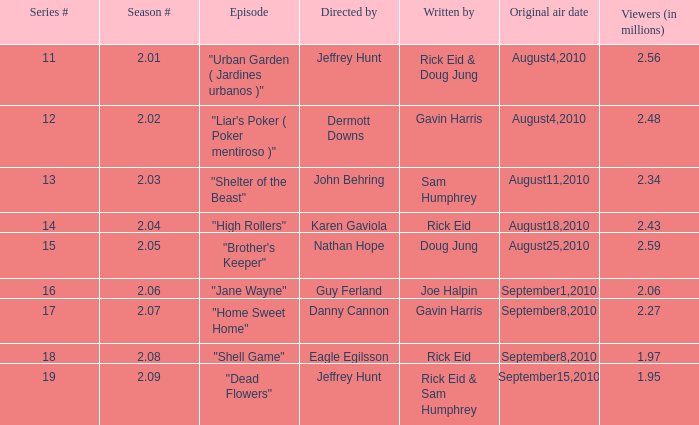08, who was the episode's writer? Rick Eid. 